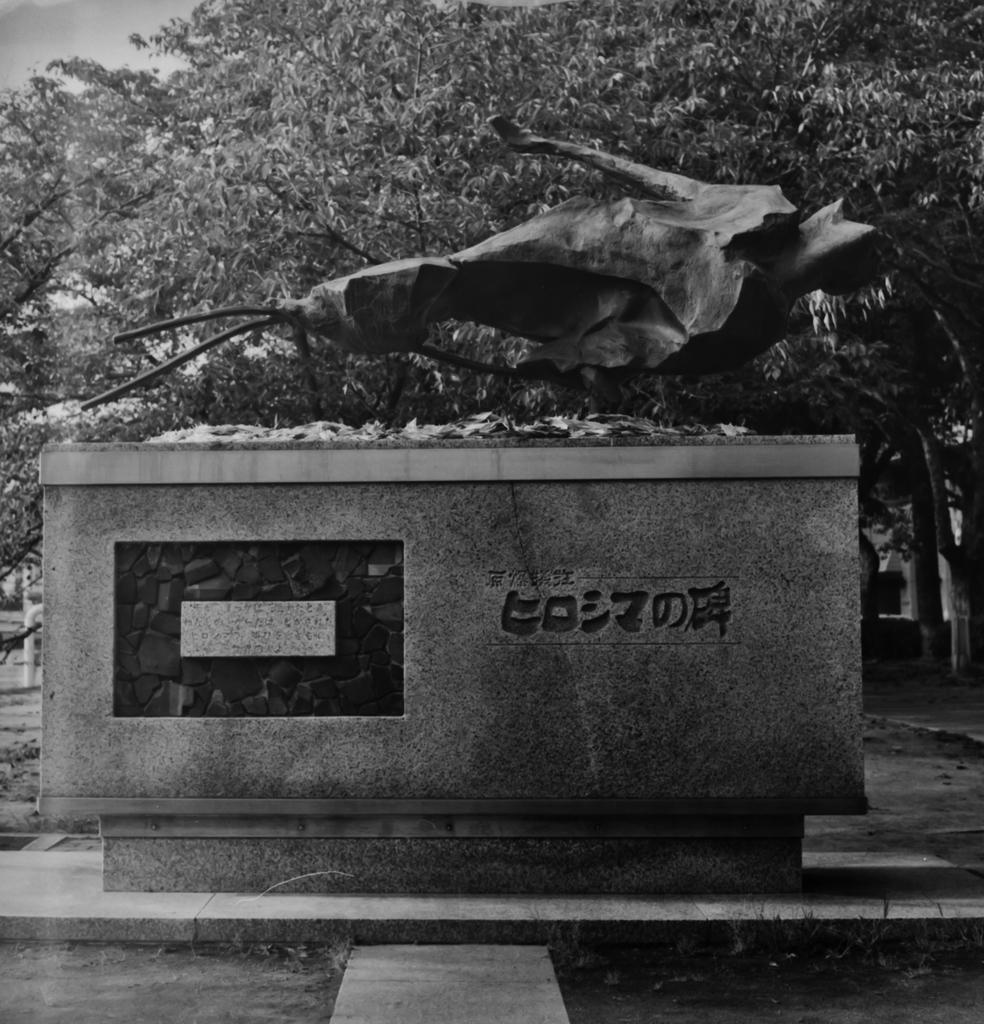What is the color scheme of the image? The image is black and white. What type of artwork is depicted in the image? The image appears to be a sculpture. Can you identify any specific features on the sculpture? There is a pillar with a name on it. What type of natural elements can be seen in the image? Trees with branches and leaves are visible in the image. How many eggs are visible on the branches of the trees in the image? There are no eggs visible on the branches of the trees in the image. What type of planes can be seen flying over the sculpture in the image? There are no planes visible in the image. 